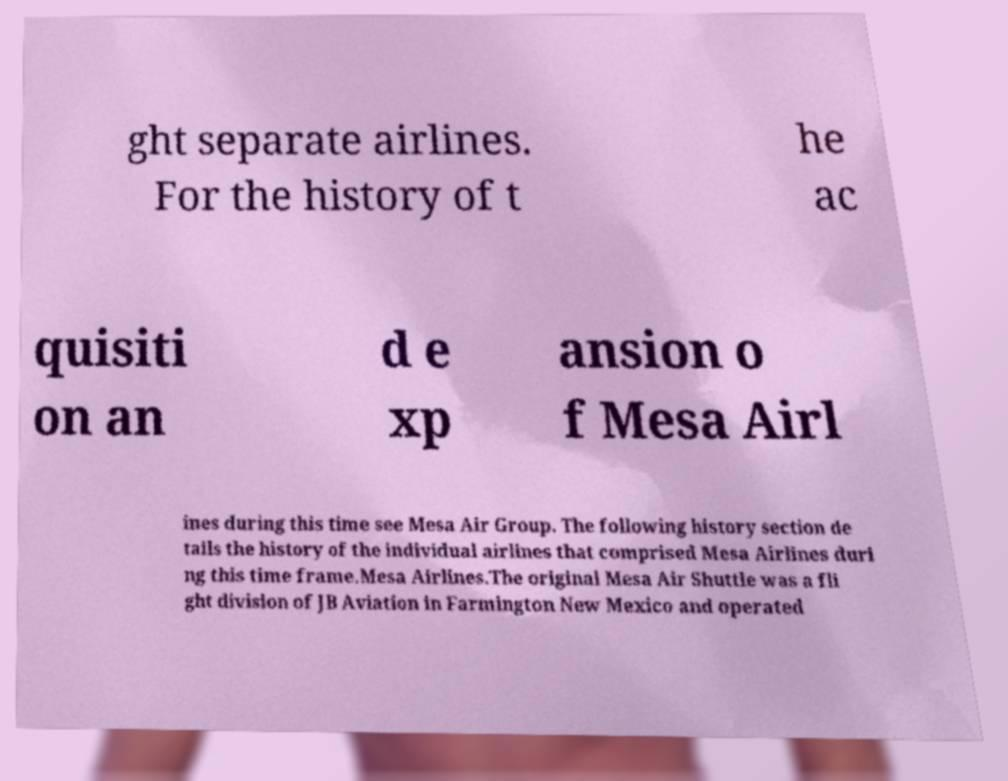There's text embedded in this image that I need extracted. Can you transcribe it verbatim? ght separate airlines. For the history of t he ac quisiti on an d e xp ansion o f Mesa Airl ines during this time see Mesa Air Group. The following history section de tails the history of the individual airlines that comprised Mesa Airlines duri ng this time frame.Mesa Airlines.The original Mesa Air Shuttle was a fli ght division of JB Aviation in Farmington New Mexico and operated 